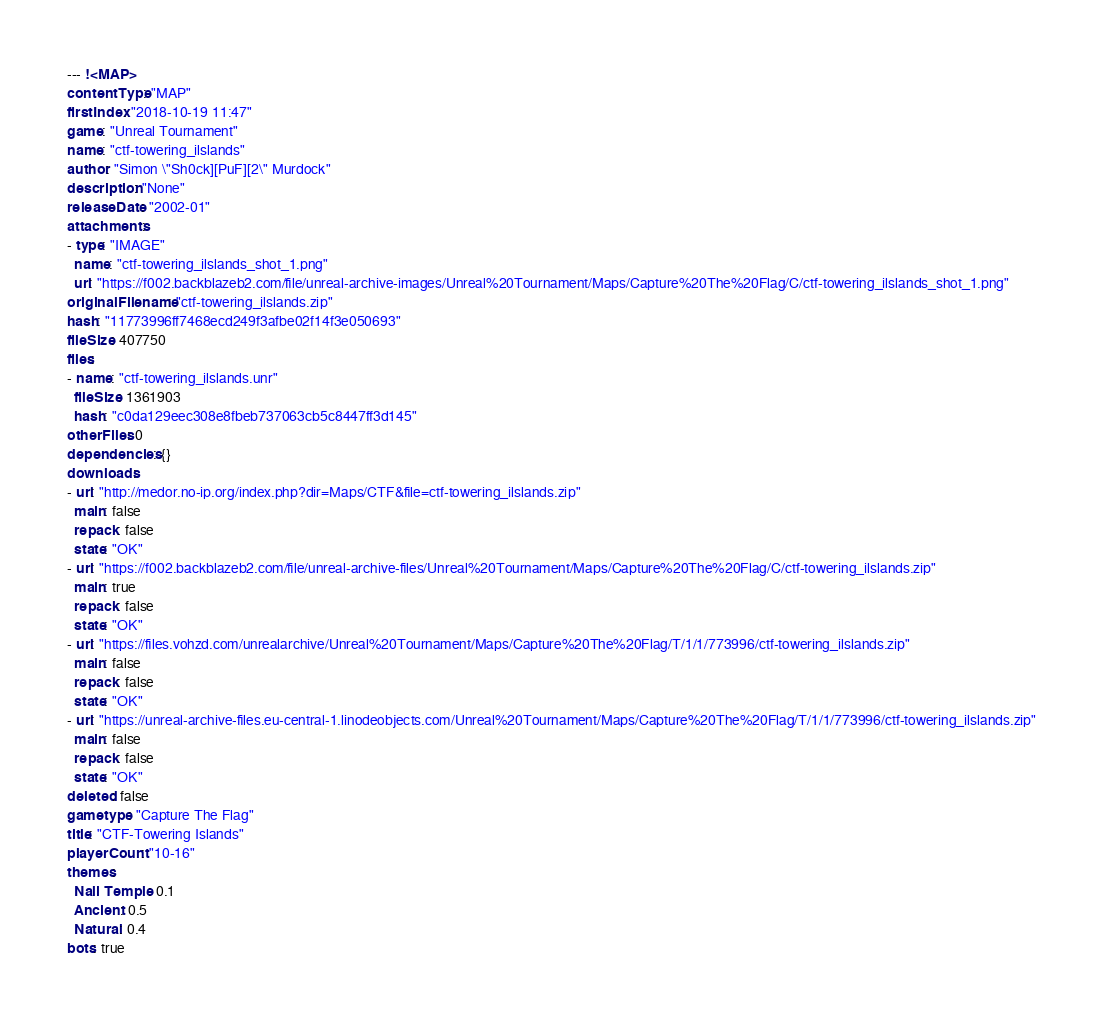Convert code to text. <code><loc_0><loc_0><loc_500><loc_500><_YAML_>--- !<MAP>
contentType: "MAP"
firstIndex: "2018-10-19 11:47"
game: "Unreal Tournament"
name: "ctf-towering_ilslands"
author: "Simon \"Sh0ck][PuF][2\" Murdock"
description: "None"
releaseDate: "2002-01"
attachments:
- type: "IMAGE"
  name: "ctf-towering_ilslands_shot_1.png"
  url: "https://f002.backblazeb2.com/file/unreal-archive-images/Unreal%20Tournament/Maps/Capture%20The%20Flag/C/ctf-towering_ilslands_shot_1.png"
originalFilename: "ctf-towering_ilslands.zip"
hash: "11773996ff7468ecd249f3afbe02f14f3e050693"
fileSize: 407750
files:
- name: "ctf-towering_ilslands.unr"
  fileSize: 1361903
  hash: "c0da129eec308e8fbeb737063cb5c8447ff3d145"
otherFiles: 0
dependencies: {}
downloads:
- url: "http://medor.no-ip.org/index.php?dir=Maps/CTF&file=ctf-towering_ilslands.zip"
  main: false
  repack: false
  state: "OK"
- url: "https://f002.backblazeb2.com/file/unreal-archive-files/Unreal%20Tournament/Maps/Capture%20The%20Flag/C/ctf-towering_ilslands.zip"
  main: true
  repack: false
  state: "OK"
- url: "https://files.vohzd.com/unrealarchive/Unreal%20Tournament/Maps/Capture%20The%20Flag/T/1/1/773996/ctf-towering_ilslands.zip"
  main: false
  repack: false
  state: "OK"
- url: "https://unreal-archive-files.eu-central-1.linodeobjects.com/Unreal%20Tournament/Maps/Capture%20The%20Flag/T/1/1/773996/ctf-towering_ilslands.zip"
  main: false
  repack: false
  state: "OK"
deleted: false
gametype: "Capture The Flag"
title: "CTF-Towering Islands"
playerCount: "10-16"
themes:
  Nali Temple: 0.1
  Ancient: 0.5
  Natural: 0.4
bots: true
</code> 